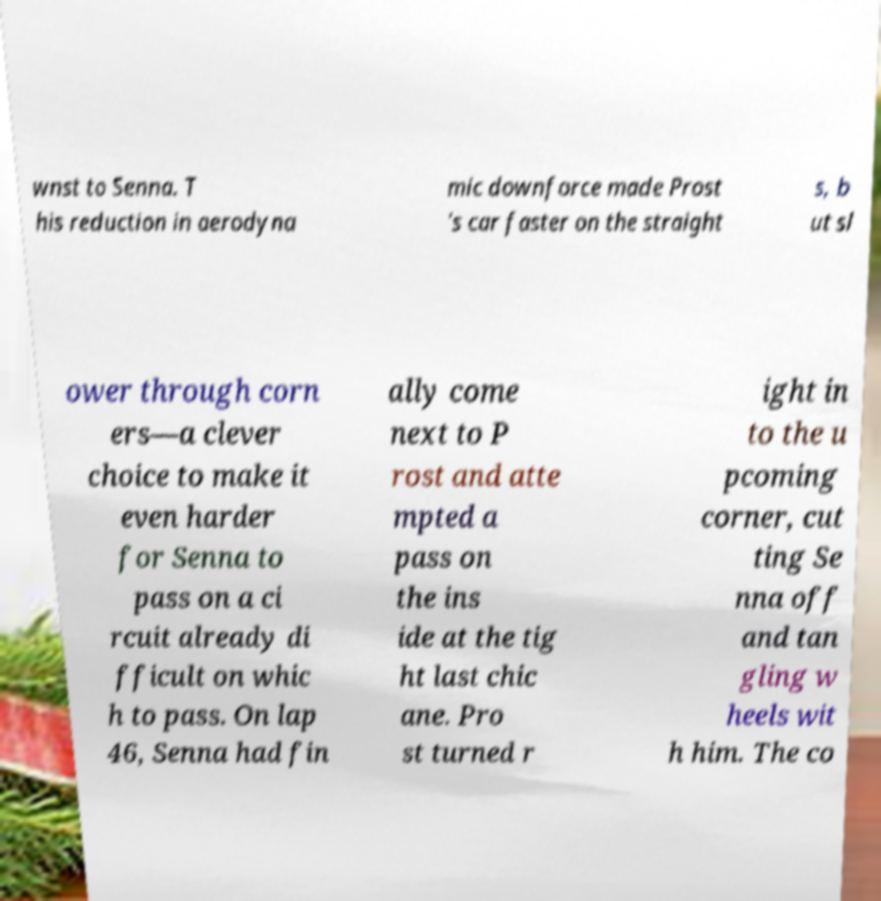Could you assist in decoding the text presented in this image and type it out clearly? wnst to Senna. T his reduction in aerodyna mic downforce made Prost 's car faster on the straight s, b ut sl ower through corn ers—a clever choice to make it even harder for Senna to pass on a ci rcuit already di fficult on whic h to pass. On lap 46, Senna had fin ally come next to P rost and atte mpted a pass on the ins ide at the tig ht last chic ane. Pro st turned r ight in to the u pcoming corner, cut ting Se nna off and tan gling w heels wit h him. The co 